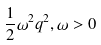Convert formula to latex. <formula><loc_0><loc_0><loc_500><loc_500>\frac { 1 } { 2 } \omega ^ { 2 } q ^ { 2 } , \omega > 0</formula> 